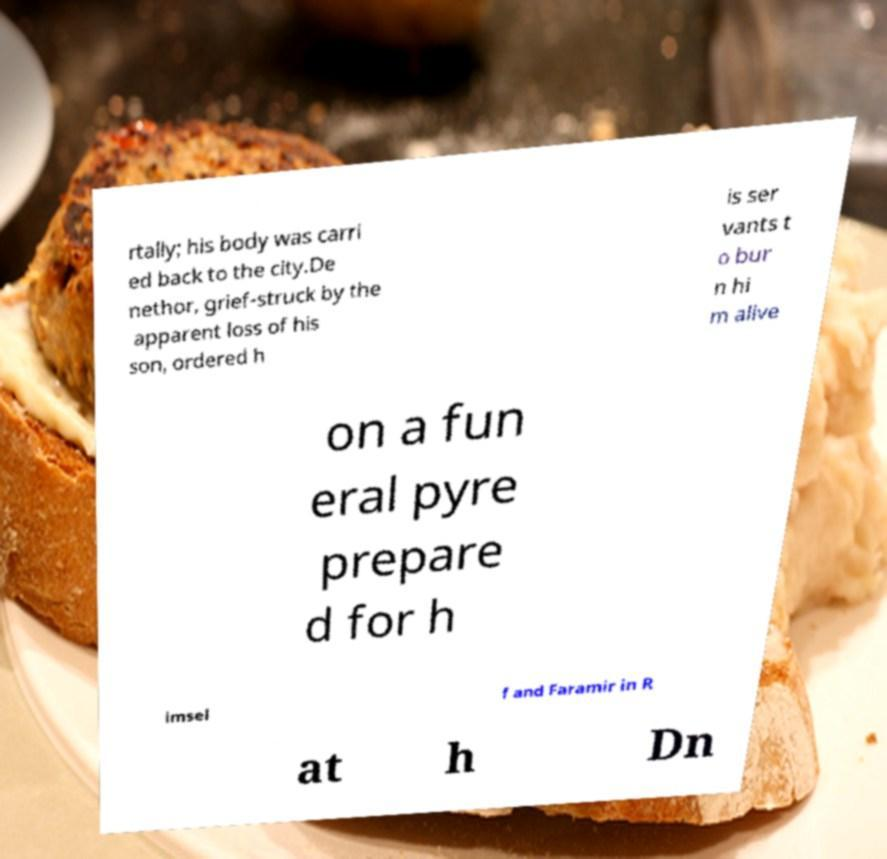Could you assist in decoding the text presented in this image and type it out clearly? rtally; his body was carri ed back to the city.De nethor, grief-struck by the apparent loss of his son, ordered h is ser vants t o bur n hi m alive on a fun eral pyre prepare d for h imsel f and Faramir in R at h Dn 